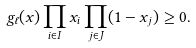<formula> <loc_0><loc_0><loc_500><loc_500>g _ { \ell } ( x ) \prod _ { i \in I } x _ { i } \prod _ { j \in J } ( 1 - x _ { j } ) \geq 0 .</formula> 